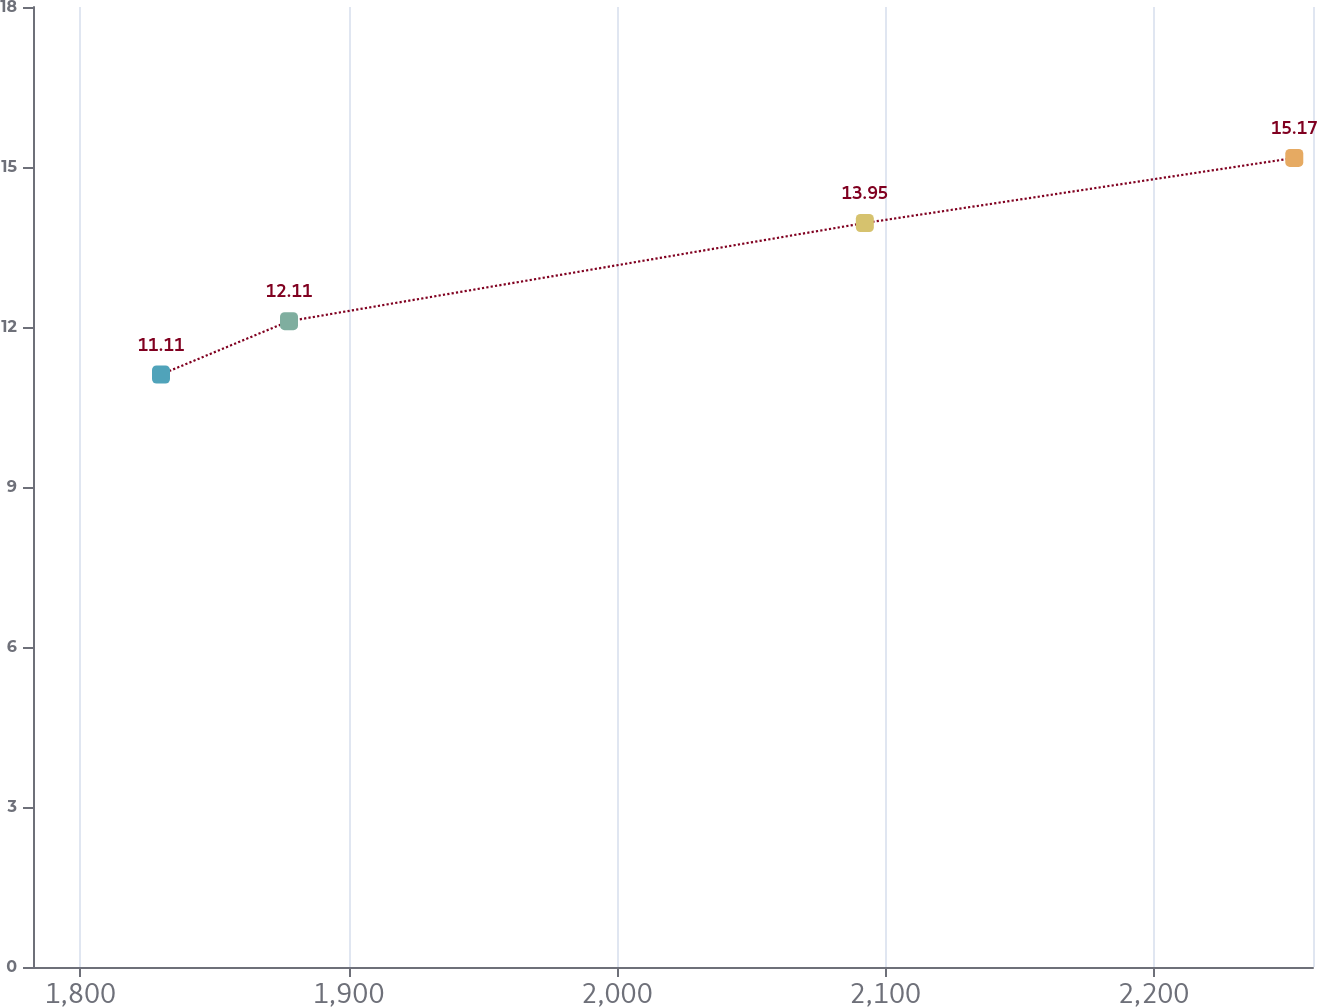Convert chart. <chart><loc_0><loc_0><loc_500><loc_500><line_chart><ecel><fcel>Unnamed: 1<nl><fcel>1830.08<fcel>11.11<nl><fcel>1877.79<fcel>12.11<nl><fcel>2092.4<fcel>13.95<nl><fcel>2252.46<fcel>15.17<nl><fcel>2307.14<fcel>17.64<nl></chart> 